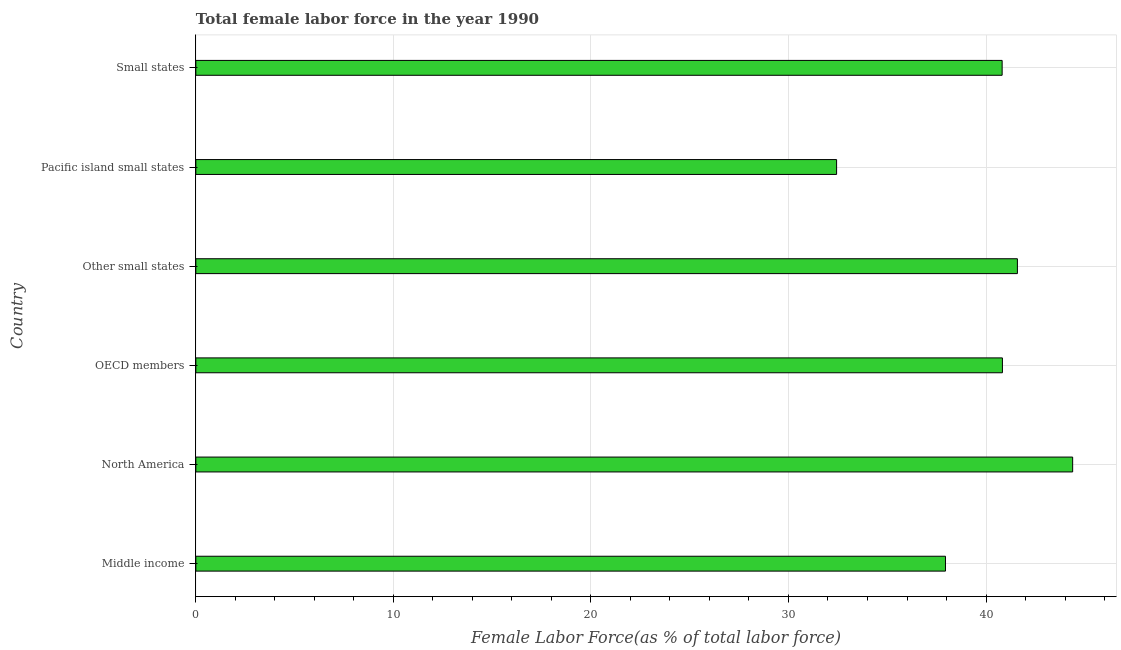Does the graph contain any zero values?
Your answer should be very brief. No. What is the title of the graph?
Your answer should be compact. Total female labor force in the year 1990. What is the label or title of the X-axis?
Keep it short and to the point. Female Labor Force(as % of total labor force). What is the total female labor force in Pacific island small states?
Your answer should be compact. 32.44. Across all countries, what is the maximum total female labor force?
Offer a very short reply. 44.39. Across all countries, what is the minimum total female labor force?
Give a very brief answer. 32.44. In which country was the total female labor force maximum?
Offer a very short reply. North America. In which country was the total female labor force minimum?
Give a very brief answer. Pacific island small states. What is the sum of the total female labor force?
Your answer should be very brief. 238. What is the difference between the total female labor force in Other small states and Small states?
Your answer should be very brief. 0.77. What is the average total female labor force per country?
Keep it short and to the point. 39.67. What is the median total female labor force?
Give a very brief answer. 40.82. What is the ratio of the total female labor force in Other small states to that in Small states?
Keep it short and to the point. 1.02. What is the difference between the highest and the second highest total female labor force?
Your answer should be very brief. 2.8. What is the difference between the highest and the lowest total female labor force?
Offer a very short reply. 11.95. How many countries are there in the graph?
Provide a short and direct response. 6. What is the difference between two consecutive major ticks on the X-axis?
Provide a short and direct response. 10. Are the values on the major ticks of X-axis written in scientific E-notation?
Your answer should be very brief. No. What is the Female Labor Force(as % of total labor force) in Middle income?
Provide a short and direct response. 37.95. What is the Female Labor Force(as % of total labor force) in North America?
Your answer should be compact. 44.39. What is the Female Labor Force(as % of total labor force) in OECD members?
Offer a very short reply. 40.83. What is the Female Labor Force(as % of total labor force) of Other small states?
Your response must be concise. 41.59. What is the Female Labor Force(as % of total labor force) of Pacific island small states?
Provide a short and direct response. 32.44. What is the Female Labor Force(as % of total labor force) of Small states?
Provide a succinct answer. 40.82. What is the difference between the Female Labor Force(as % of total labor force) in Middle income and North America?
Provide a succinct answer. -6.44. What is the difference between the Female Labor Force(as % of total labor force) in Middle income and OECD members?
Your response must be concise. -2.88. What is the difference between the Female Labor Force(as % of total labor force) in Middle income and Other small states?
Provide a short and direct response. -3.64. What is the difference between the Female Labor Force(as % of total labor force) in Middle income and Pacific island small states?
Your answer should be very brief. 5.51. What is the difference between the Female Labor Force(as % of total labor force) in Middle income and Small states?
Keep it short and to the point. -2.87. What is the difference between the Female Labor Force(as % of total labor force) in North America and OECD members?
Make the answer very short. 3.56. What is the difference between the Female Labor Force(as % of total labor force) in North America and Other small states?
Provide a short and direct response. 2.8. What is the difference between the Female Labor Force(as % of total labor force) in North America and Pacific island small states?
Your answer should be compact. 11.95. What is the difference between the Female Labor Force(as % of total labor force) in North America and Small states?
Your answer should be compact. 3.57. What is the difference between the Female Labor Force(as % of total labor force) in OECD members and Other small states?
Offer a very short reply. -0.76. What is the difference between the Female Labor Force(as % of total labor force) in OECD members and Pacific island small states?
Make the answer very short. 8.39. What is the difference between the Female Labor Force(as % of total labor force) in OECD members and Small states?
Make the answer very short. 0.01. What is the difference between the Female Labor Force(as % of total labor force) in Other small states and Pacific island small states?
Provide a short and direct response. 9.15. What is the difference between the Female Labor Force(as % of total labor force) in Other small states and Small states?
Your response must be concise. 0.77. What is the difference between the Female Labor Force(as % of total labor force) in Pacific island small states and Small states?
Provide a succinct answer. -8.38. What is the ratio of the Female Labor Force(as % of total labor force) in Middle income to that in North America?
Your response must be concise. 0.85. What is the ratio of the Female Labor Force(as % of total labor force) in Middle income to that in OECD members?
Your answer should be very brief. 0.93. What is the ratio of the Female Labor Force(as % of total labor force) in Middle income to that in Other small states?
Keep it short and to the point. 0.91. What is the ratio of the Female Labor Force(as % of total labor force) in Middle income to that in Pacific island small states?
Your answer should be compact. 1.17. What is the ratio of the Female Labor Force(as % of total labor force) in North America to that in OECD members?
Ensure brevity in your answer.  1.09. What is the ratio of the Female Labor Force(as % of total labor force) in North America to that in Other small states?
Keep it short and to the point. 1.07. What is the ratio of the Female Labor Force(as % of total labor force) in North America to that in Pacific island small states?
Provide a succinct answer. 1.37. What is the ratio of the Female Labor Force(as % of total labor force) in North America to that in Small states?
Your answer should be compact. 1.09. What is the ratio of the Female Labor Force(as % of total labor force) in OECD members to that in Other small states?
Make the answer very short. 0.98. What is the ratio of the Female Labor Force(as % of total labor force) in OECD members to that in Pacific island small states?
Your answer should be compact. 1.26. What is the ratio of the Female Labor Force(as % of total labor force) in OECD members to that in Small states?
Provide a succinct answer. 1. What is the ratio of the Female Labor Force(as % of total labor force) in Other small states to that in Pacific island small states?
Provide a short and direct response. 1.28. What is the ratio of the Female Labor Force(as % of total labor force) in Pacific island small states to that in Small states?
Your answer should be very brief. 0.8. 